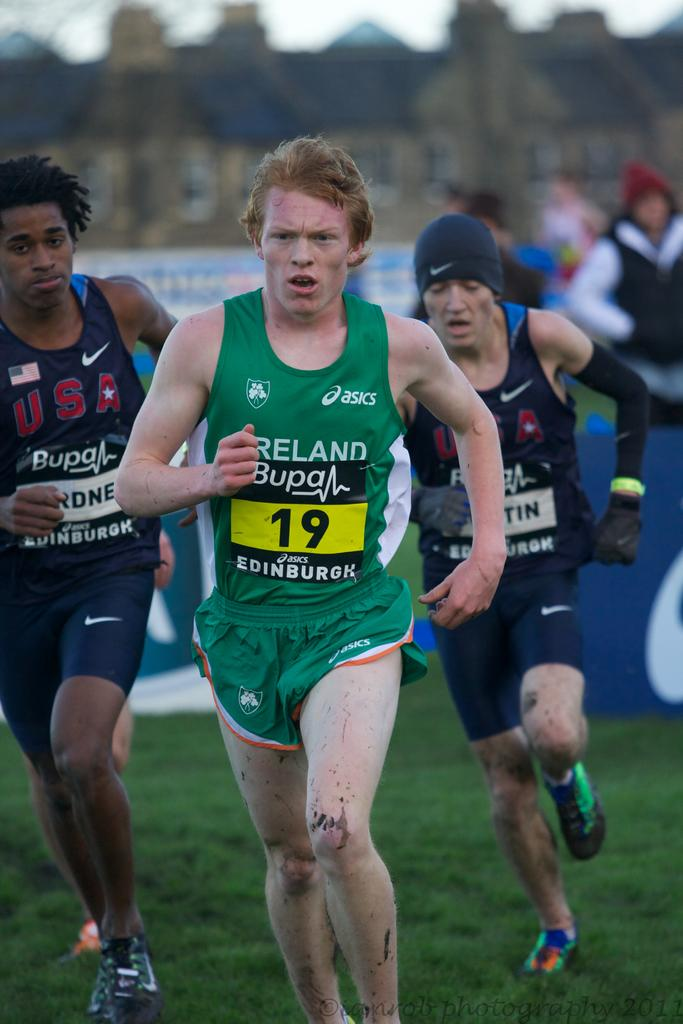<image>
Write a terse but informative summary of the picture. A runner wearing a number 19 badge is representing Ireland. 